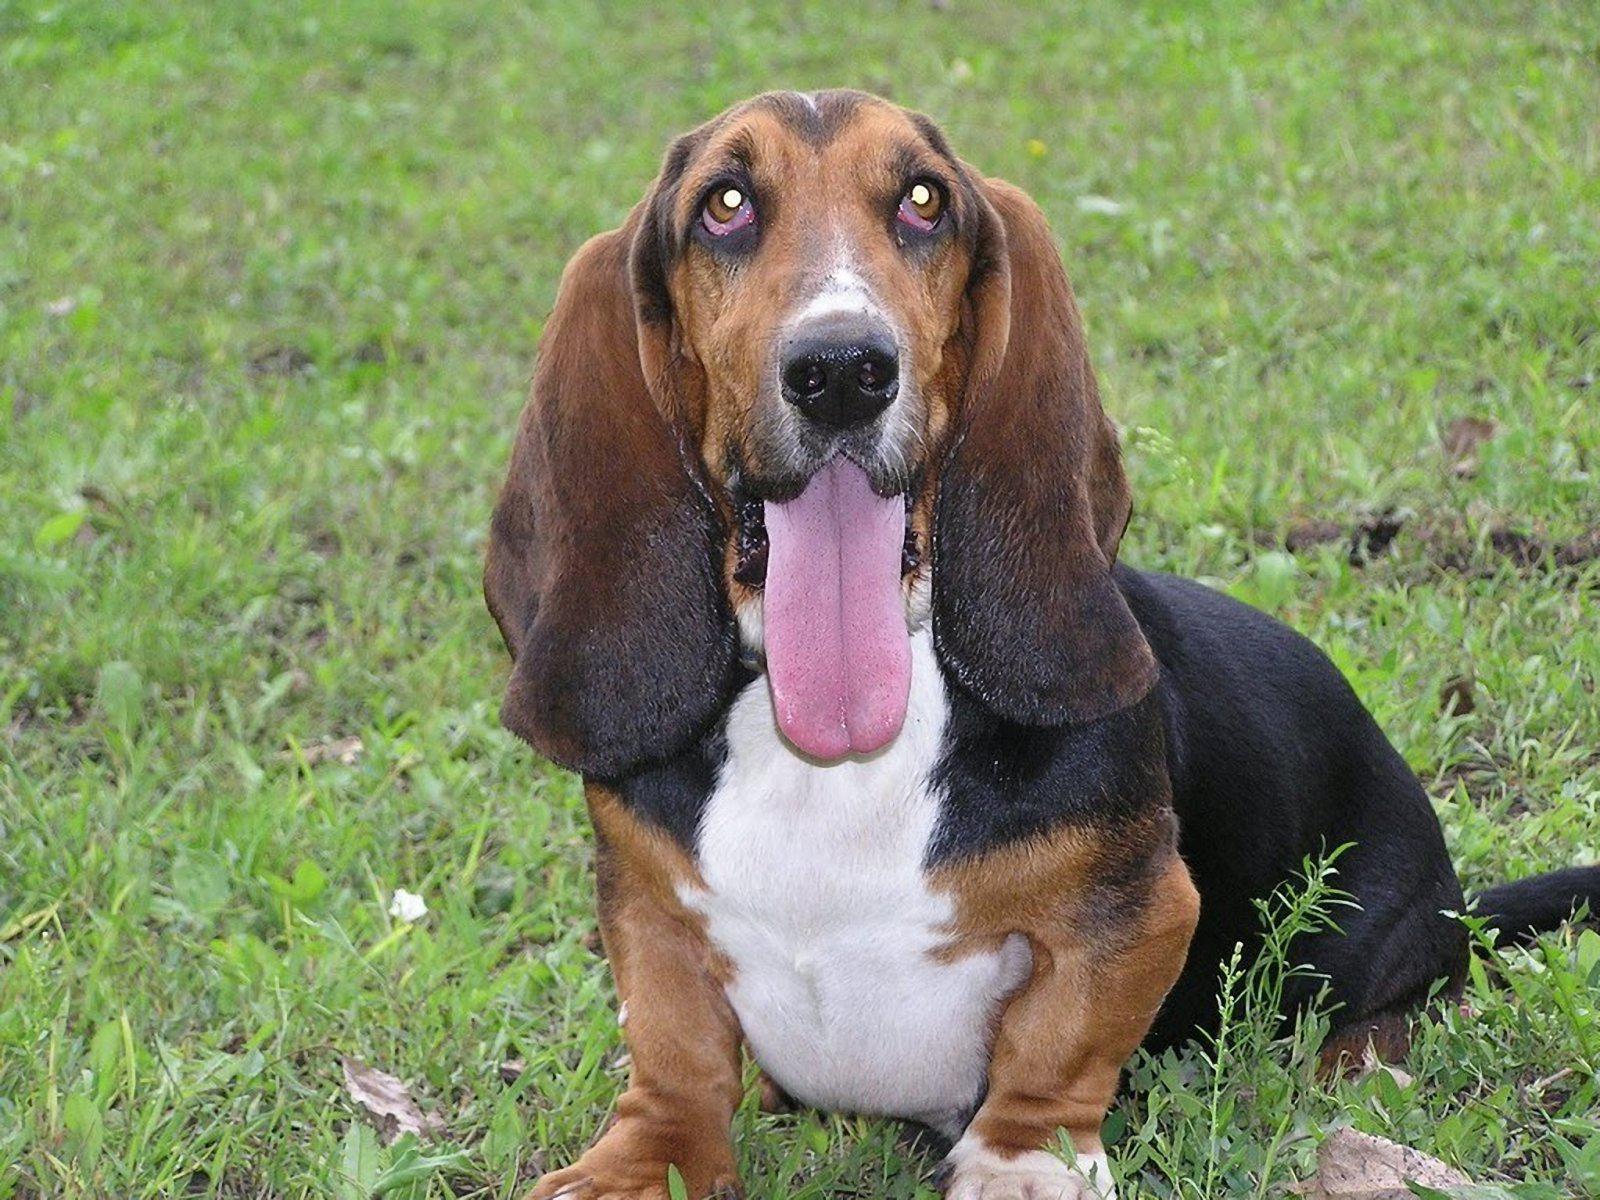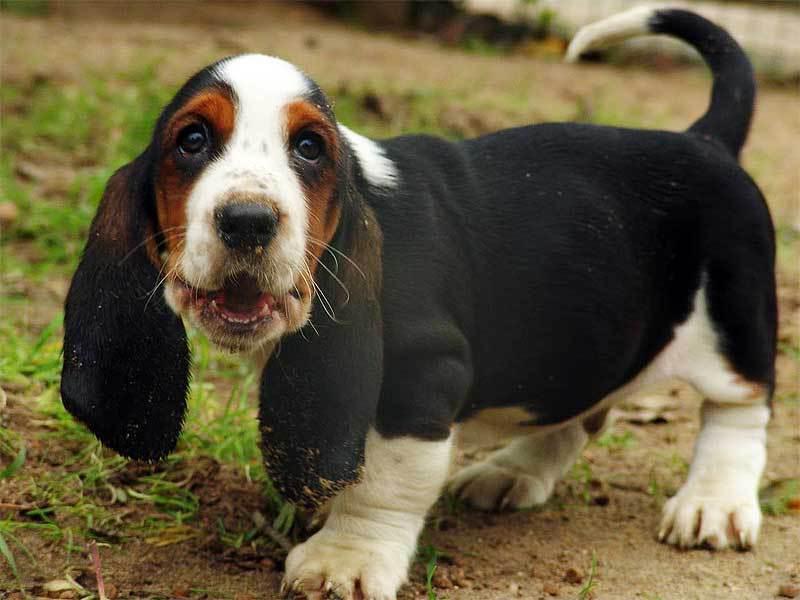The first image is the image on the left, the second image is the image on the right. For the images displayed, is the sentence "There are at most two dogs." factually correct? Answer yes or no. Yes. 